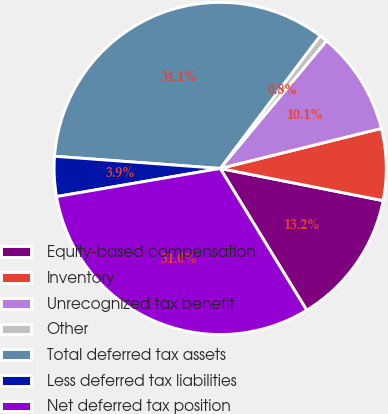<chart> <loc_0><loc_0><loc_500><loc_500><pie_chart><fcel>Equity-based compensation<fcel>Inventory<fcel>Unrecognized tax benefit<fcel>Other<fcel>Total deferred tax assets<fcel>Less deferred tax liabilities<fcel>Net deferred tax position<nl><fcel>13.18%<fcel>6.98%<fcel>10.08%<fcel>0.77%<fcel>34.11%<fcel>3.88%<fcel>31.01%<nl></chart> 